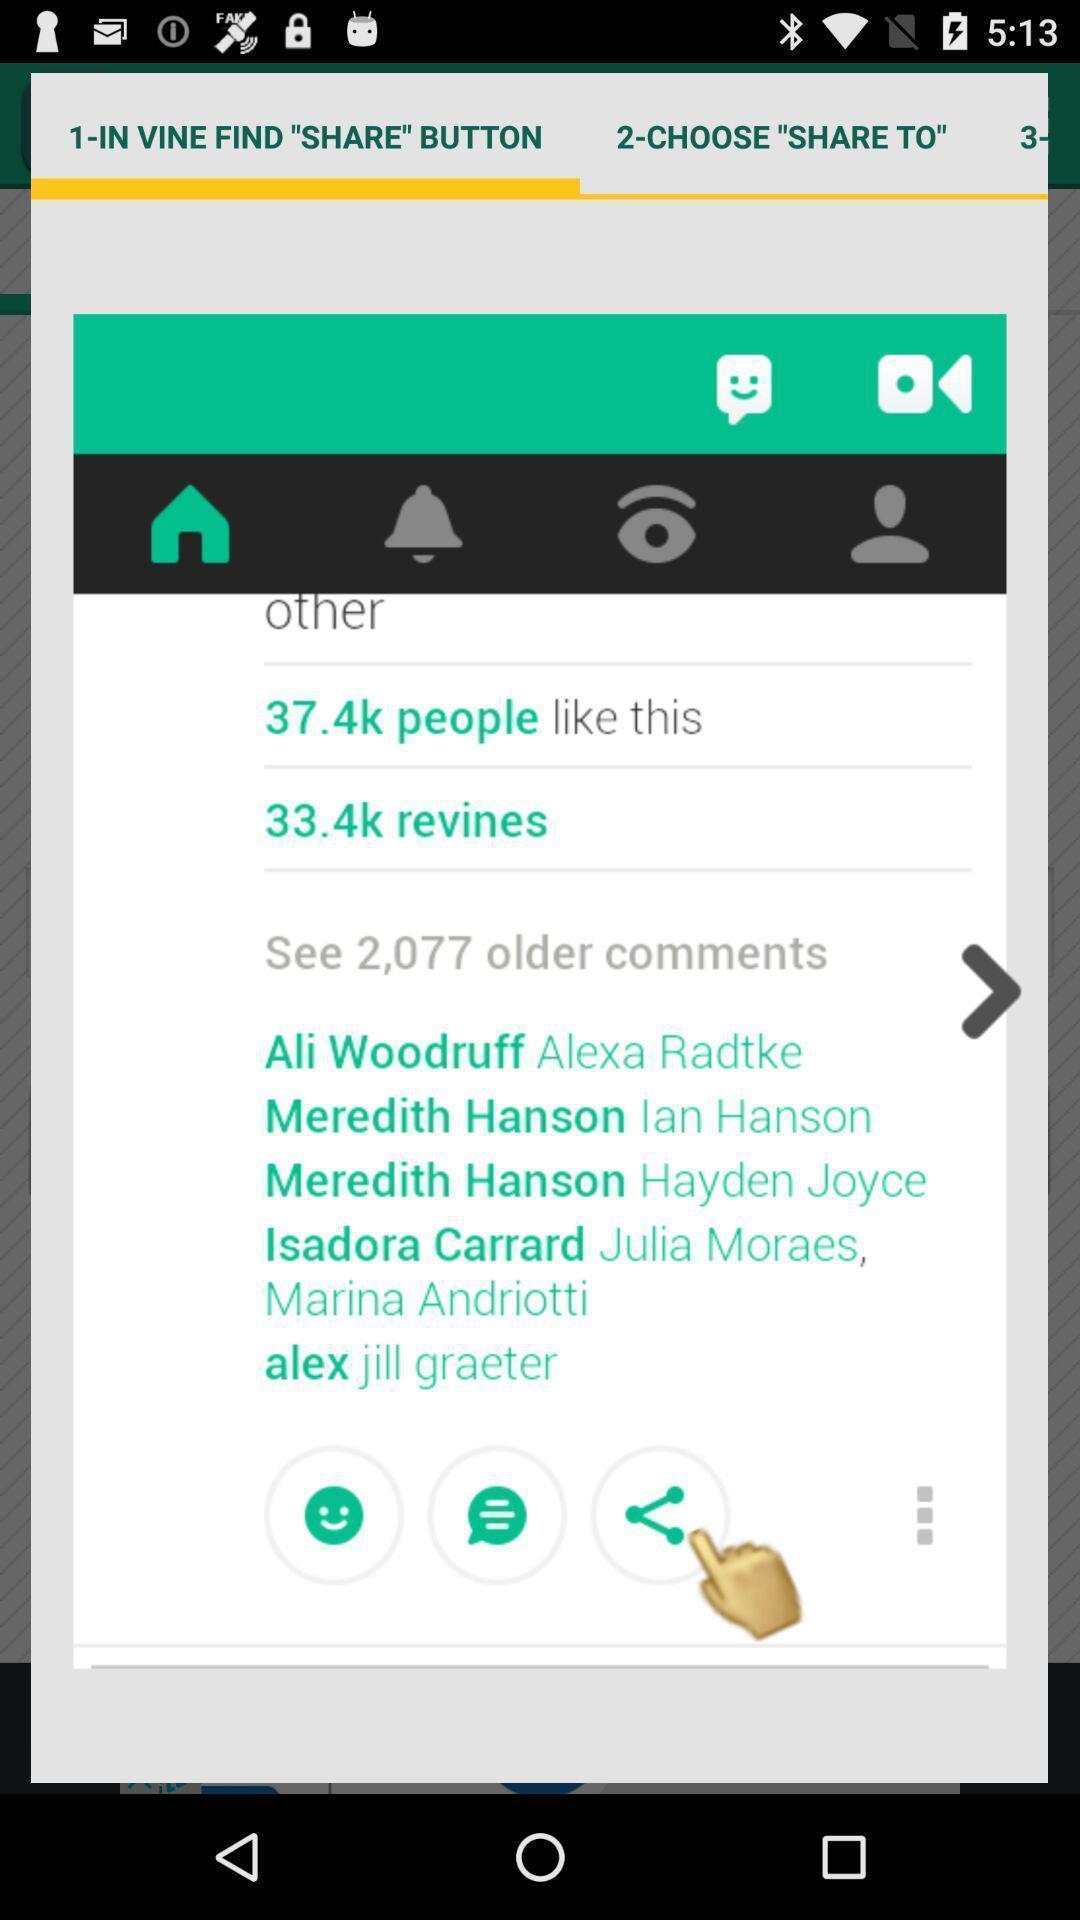Provide a description of this screenshot. Pop-up window showing likes and comments. 